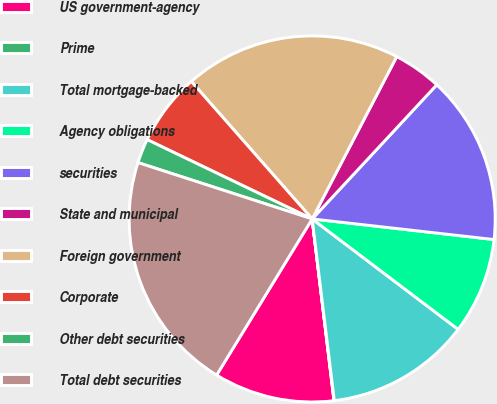Convert chart to OTSL. <chart><loc_0><loc_0><loc_500><loc_500><pie_chart><fcel>US government-agency<fcel>Prime<fcel>Total mortgage-backed<fcel>Agency obligations<fcel>securities<fcel>State and municipal<fcel>Foreign government<fcel>Corporate<fcel>Other debt securities<fcel>Total debt securities<nl><fcel>10.64%<fcel>0.03%<fcel>12.76%<fcel>8.51%<fcel>14.88%<fcel>4.27%<fcel>19.12%<fcel>6.39%<fcel>2.15%<fcel>21.24%<nl></chart> 